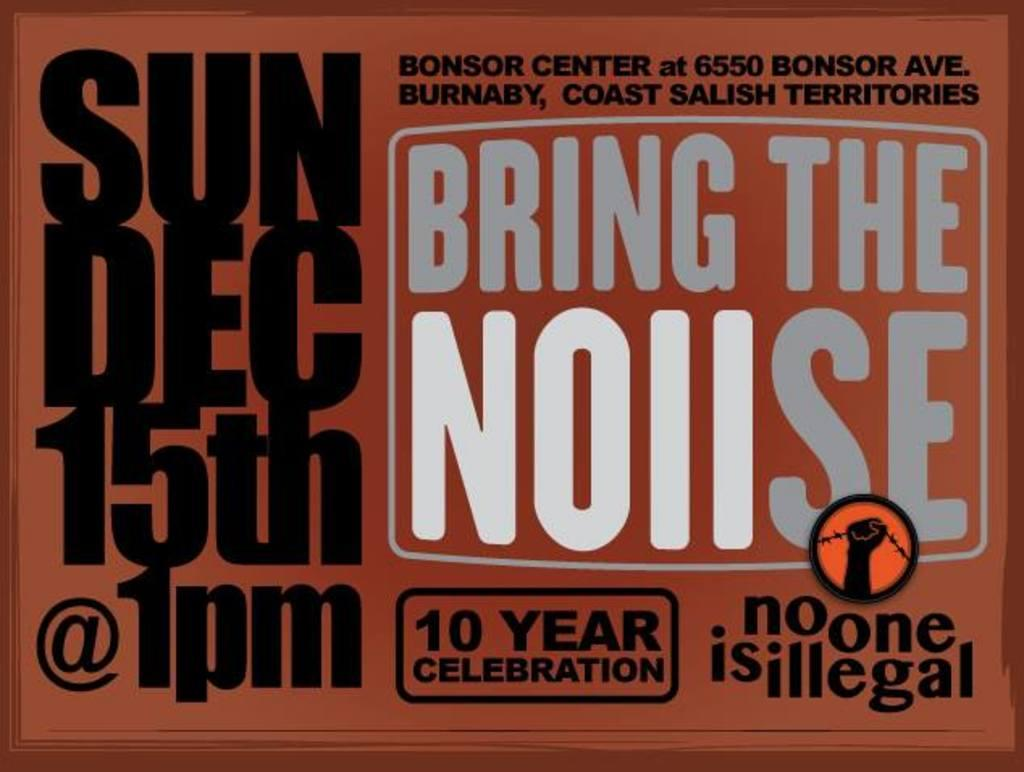<image>
Render a clear and concise summary of the photo. An advertisement for Bring the Noiise, 10 Year Celebration, on Sun Dec 15th @ 1pm. 